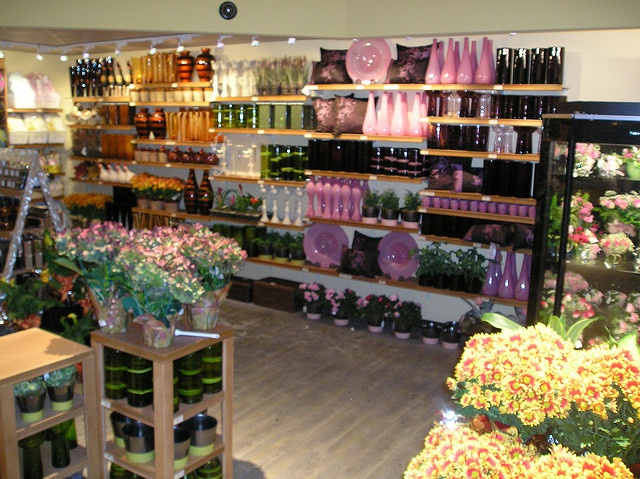Describe the objects in this image and their specific colors. I can see potted plant in gray, khaki, darkgreen, and lightyellow tones, potted plant in gray, khaki, and black tones, potted plant in gray, teal, and green tones, potted plant in gray, teal, and darkgreen tones, and vase in gray, purple, brown, and black tones in this image. 